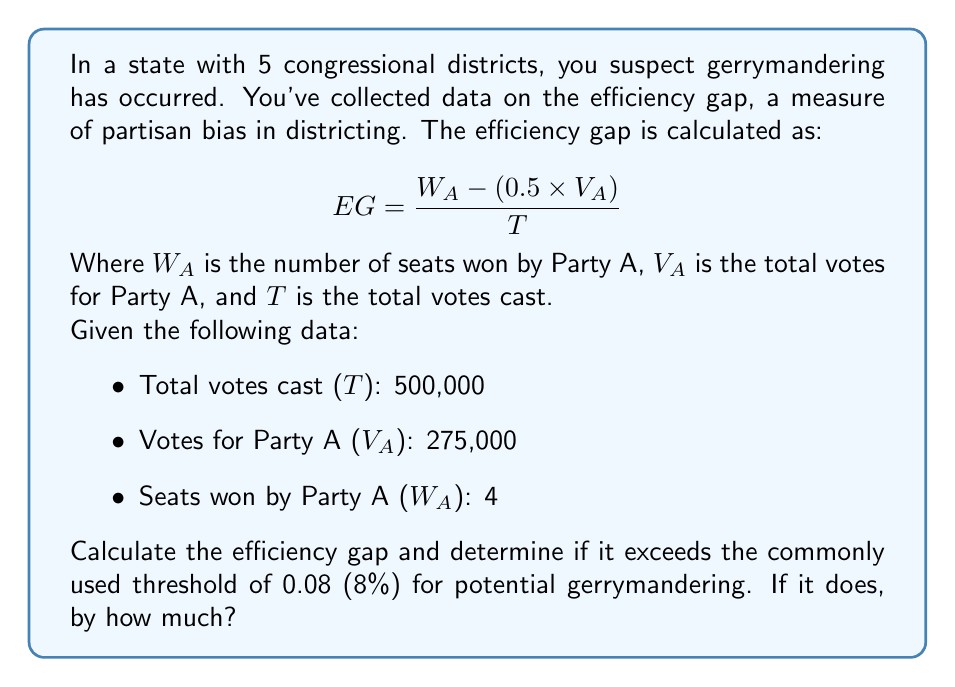Provide a solution to this math problem. Let's approach this step-by-step:

1) First, we need to plug our values into the efficiency gap formula:

   $$ EG = \frac{W_A - (0.5 \times V_A)}{T} $$

2) We have:
   - $W_A = 4$
   - $V_A = 275,000$
   - $T = 500,000$

3) Let's substitute these values:

   $$ EG = \frac{4 - (0.5 \times 275,000)}{500,000} $$

4) Now, let's solve the parentheses:

   $$ EG = \frac{4 - 137,500}{500,000} $$

5) Subtract in the numerator:

   $$ EG = \frac{-137,496}{500,000} $$

6) Divide:

   $$ EG = -0.274992 $$

7) Convert to a percentage:

   $$ EG = -27.4992\% $$

8) The absolute value of this (27.4992%) exceeds the 8% threshold.

9) To determine by how much it exceeds the threshold:

   $27.4992\% - 8\% = 19.4992\%$

This significant deviation from the 8% threshold suggests potential gerrymandering, favoring Party A despite them receiving only 55% of the votes (275,000 / 500,000 = 0.55 or 55%).
Answer: The efficiency gap is -27.4992%, which exceeds the 8% threshold by 19.4992%, indicating potential gerrymandering. 